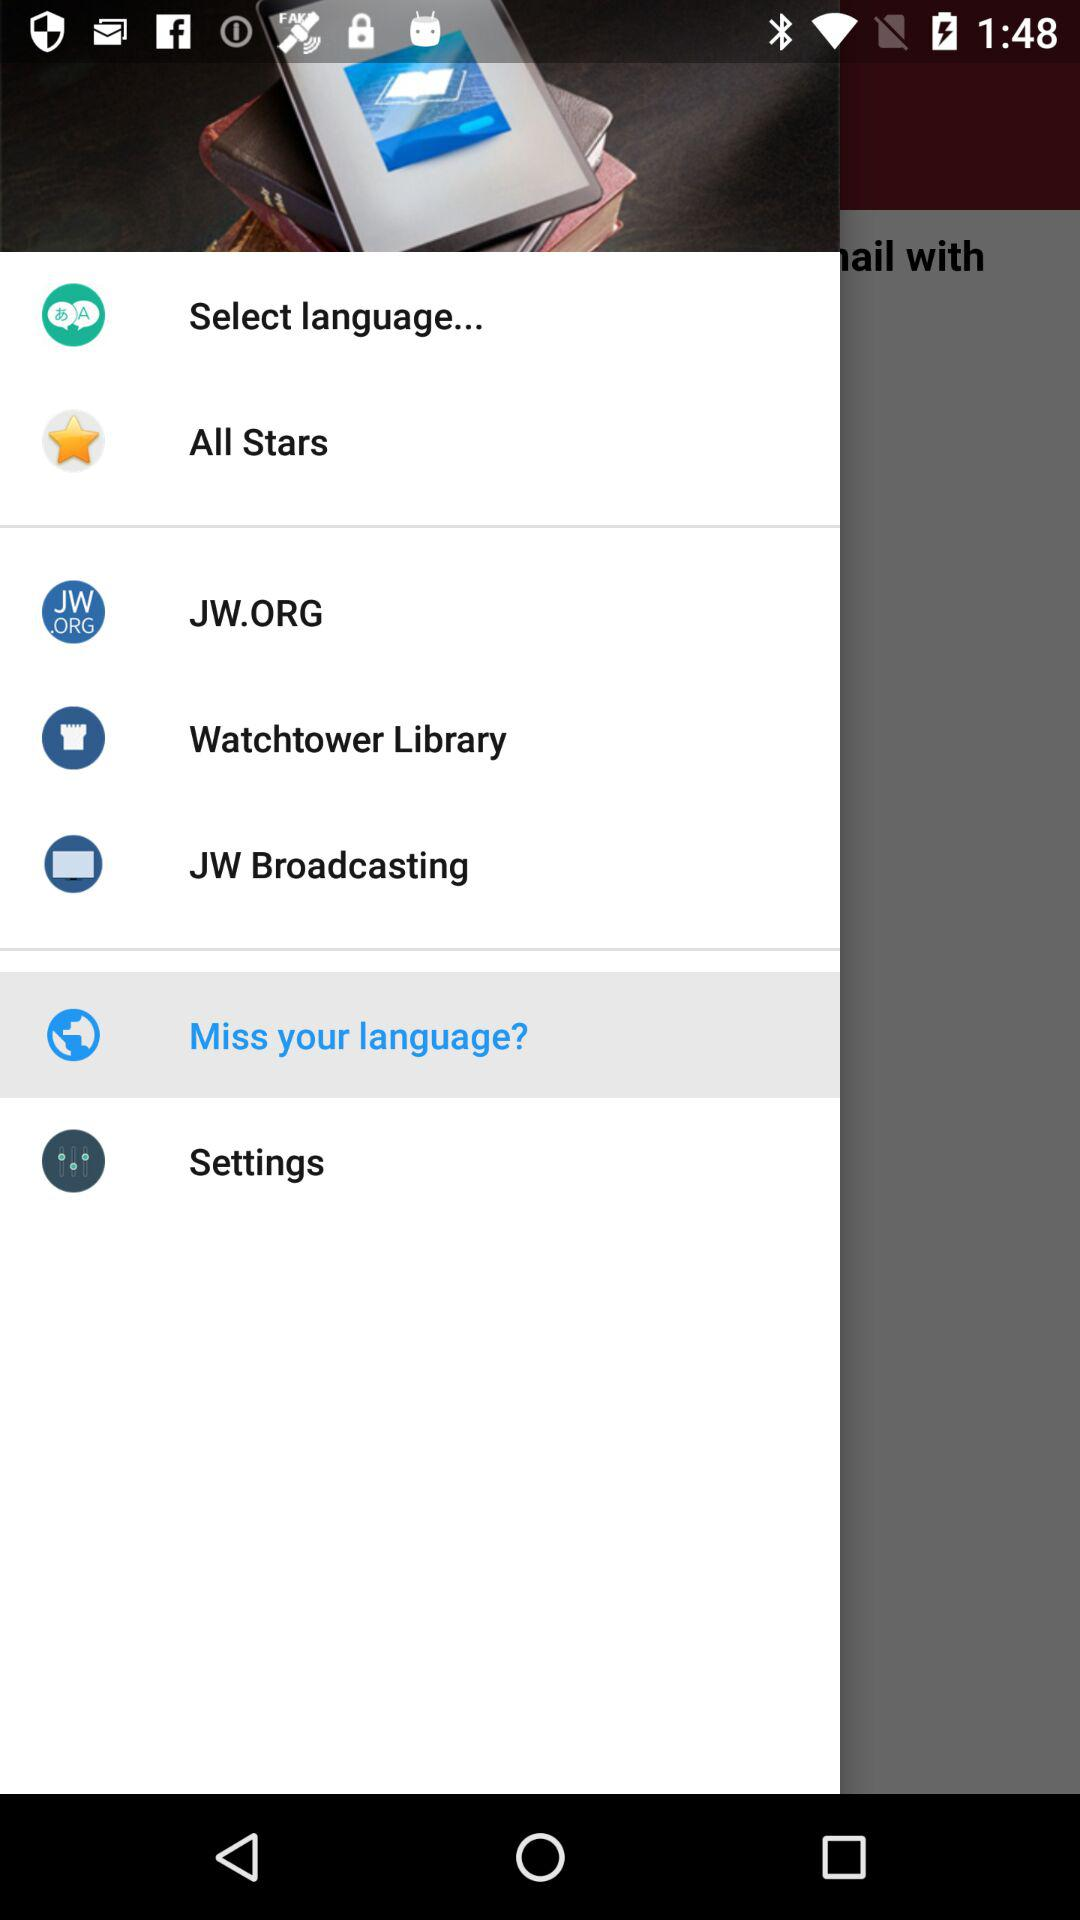Which item is selected? The selected item is "Miss your language?". 